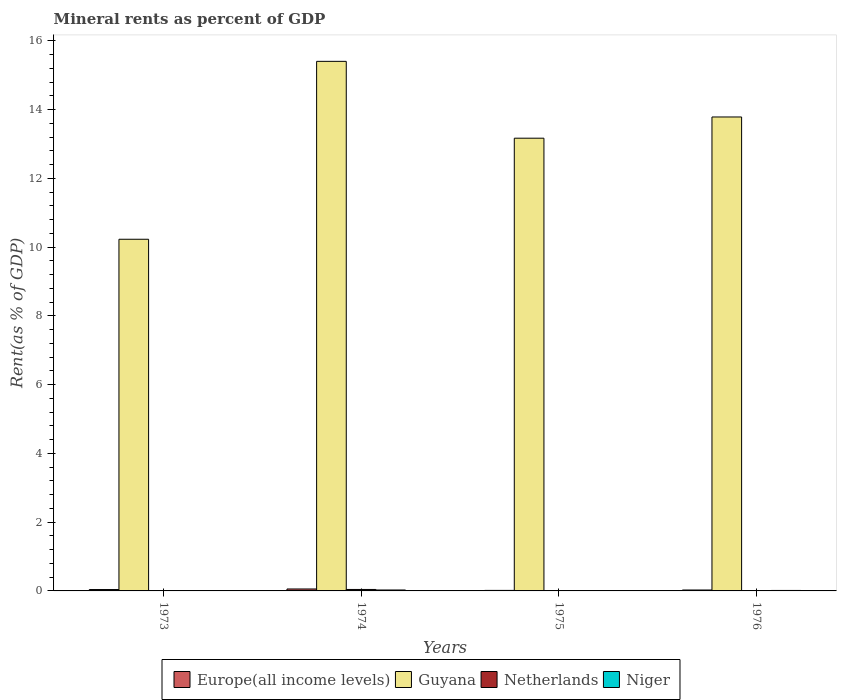Are the number of bars on each tick of the X-axis equal?
Offer a very short reply. Yes. What is the label of the 2nd group of bars from the left?
Make the answer very short. 1974. In how many cases, is the number of bars for a given year not equal to the number of legend labels?
Your answer should be compact. 0. What is the mineral rent in Netherlands in 1976?
Make the answer very short. 0. Across all years, what is the maximum mineral rent in Netherlands?
Provide a succinct answer. 0.04. Across all years, what is the minimum mineral rent in Netherlands?
Your response must be concise. 0. In which year was the mineral rent in Guyana maximum?
Keep it short and to the point. 1974. What is the total mineral rent in Niger in the graph?
Provide a succinct answer. 0.05. What is the difference between the mineral rent in Europe(all income levels) in 1974 and that in 1976?
Give a very brief answer. 0.03. What is the difference between the mineral rent in Guyana in 1973 and the mineral rent in Netherlands in 1976?
Offer a terse response. 10.23. What is the average mineral rent in Niger per year?
Your response must be concise. 0.01. In the year 1975, what is the difference between the mineral rent in Guyana and mineral rent in Europe(all income levels)?
Offer a very short reply. 13.15. What is the ratio of the mineral rent in Niger in 1973 to that in 1976?
Make the answer very short. 0.27. Is the mineral rent in Netherlands in 1974 less than that in 1976?
Ensure brevity in your answer.  No. What is the difference between the highest and the second highest mineral rent in Europe(all income levels)?
Give a very brief answer. 0.02. What is the difference between the highest and the lowest mineral rent in Netherlands?
Give a very brief answer. 0.04. Is the sum of the mineral rent in Europe(all income levels) in 1974 and 1976 greater than the maximum mineral rent in Niger across all years?
Keep it short and to the point. Yes. What does the 4th bar from the left in 1974 represents?
Your answer should be very brief. Niger. What does the 1st bar from the right in 1974 represents?
Your answer should be very brief. Niger. How many years are there in the graph?
Make the answer very short. 4. Where does the legend appear in the graph?
Ensure brevity in your answer.  Bottom center. How many legend labels are there?
Provide a succinct answer. 4. How are the legend labels stacked?
Offer a very short reply. Horizontal. What is the title of the graph?
Ensure brevity in your answer.  Mineral rents as percent of GDP. What is the label or title of the X-axis?
Provide a short and direct response. Years. What is the label or title of the Y-axis?
Your answer should be very brief. Rent(as % of GDP). What is the Rent(as % of GDP) of Europe(all income levels) in 1973?
Your answer should be compact. 0.04. What is the Rent(as % of GDP) in Guyana in 1973?
Give a very brief answer. 10.23. What is the Rent(as % of GDP) of Netherlands in 1973?
Give a very brief answer. 0.01. What is the Rent(as % of GDP) of Niger in 1973?
Ensure brevity in your answer.  0. What is the Rent(as % of GDP) of Europe(all income levels) in 1974?
Offer a very short reply. 0.06. What is the Rent(as % of GDP) of Guyana in 1974?
Offer a terse response. 15.4. What is the Rent(as % of GDP) in Netherlands in 1974?
Ensure brevity in your answer.  0.04. What is the Rent(as % of GDP) of Niger in 1974?
Provide a short and direct response. 0.03. What is the Rent(as % of GDP) in Europe(all income levels) in 1975?
Your answer should be very brief. 0.02. What is the Rent(as % of GDP) in Guyana in 1975?
Your answer should be very brief. 13.17. What is the Rent(as % of GDP) of Netherlands in 1975?
Make the answer very short. 0. What is the Rent(as % of GDP) of Niger in 1975?
Provide a succinct answer. 0.01. What is the Rent(as % of GDP) in Europe(all income levels) in 1976?
Provide a succinct answer. 0.03. What is the Rent(as % of GDP) of Guyana in 1976?
Offer a terse response. 13.78. What is the Rent(as % of GDP) in Netherlands in 1976?
Offer a terse response. 0. What is the Rent(as % of GDP) of Niger in 1976?
Give a very brief answer. 0.01. Across all years, what is the maximum Rent(as % of GDP) of Europe(all income levels)?
Make the answer very short. 0.06. Across all years, what is the maximum Rent(as % of GDP) in Guyana?
Give a very brief answer. 15.4. Across all years, what is the maximum Rent(as % of GDP) in Netherlands?
Keep it short and to the point. 0.04. Across all years, what is the maximum Rent(as % of GDP) of Niger?
Your response must be concise. 0.03. Across all years, what is the minimum Rent(as % of GDP) of Europe(all income levels)?
Provide a succinct answer. 0.02. Across all years, what is the minimum Rent(as % of GDP) of Guyana?
Give a very brief answer. 10.23. Across all years, what is the minimum Rent(as % of GDP) of Netherlands?
Give a very brief answer. 0. Across all years, what is the minimum Rent(as % of GDP) of Niger?
Give a very brief answer. 0. What is the total Rent(as % of GDP) of Europe(all income levels) in the graph?
Your answer should be compact. 0.14. What is the total Rent(as % of GDP) in Guyana in the graph?
Provide a short and direct response. 52.58. What is the total Rent(as % of GDP) of Netherlands in the graph?
Your answer should be very brief. 0.06. What is the total Rent(as % of GDP) of Niger in the graph?
Provide a succinct answer. 0.05. What is the difference between the Rent(as % of GDP) in Europe(all income levels) in 1973 and that in 1974?
Ensure brevity in your answer.  -0.02. What is the difference between the Rent(as % of GDP) of Guyana in 1973 and that in 1974?
Give a very brief answer. -5.17. What is the difference between the Rent(as % of GDP) in Netherlands in 1973 and that in 1974?
Ensure brevity in your answer.  -0.03. What is the difference between the Rent(as % of GDP) of Niger in 1973 and that in 1974?
Offer a very short reply. -0.02. What is the difference between the Rent(as % of GDP) in Europe(all income levels) in 1973 and that in 1975?
Ensure brevity in your answer.  0.02. What is the difference between the Rent(as % of GDP) in Guyana in 1973 and that in 1975?
Provide a succinct answer. -2.94. What is the difference between the Rent(as % of GDP) in Netherlands in 1973 and that in 1975?
Provide a short and direct response. 0.01. What is the difference between the Rent(as % of GDP) in Niger in 1973 and that in 1975?
Make the answer very short. -0. What is the difference between the Rent(as % of GDP) in Europe(all income levels) in 1973 and that in 1976?
Your answer should be very brief. 0.01. What is the difference between the Rent(as % of GDP) in Guyana in 1973 and that in 1976?
Give a very brief answer. -3.56. What is the difference between the Rent(as % of GDP) of Netherlands in 1973 and that in 1976?
Your answer should be compact. 0.01. What is the difference between the Rent(as % of GDP) of Niger in 1973 and that in 1976?
Make the answer very short. -0.01. What is the difference between the Rent(as % of GDP) in Europe(all income levels) in 1974 and that in 1975?
Provide a short and direct response. 0.04. What is the difference between the Rent(as % of GDP) of Guyana in 1974 and that in 1975?
Provide a short and direct response. 2.23. What is the difference between the Rent(as % of GDP) of Netherlands in 1974 and that in 1975?
Offer a terse response. 0.04. What is the difference between the Rent(as % of GDP) of Niger in 1974 and that in 1975?
Your answer should be compact. 0.02. What is the difference between the Rent(as % of GDP) of Europe(all income levels) in 1974 and that in 1976?
Offer a very short reply. 0.03. What is the difference between the Rent(as % of GDP) in Guyana in 1974 and that in 1976?
Offer a terse response. 1.62. What is the difference between the Rent(as % of GDP) of Netherlands in 1974 and that in 1976?
Your answer should be very brief. 0.04. What is the difference between the Rent(as % of GDP) of Niger in 1974 and that in 1976?
Your answer should be very brief. 0.01. What is the difference between the Rent(as % of GDP) of Europe(all income levels) in 1975 and that in 1976?
Your response must be concise. -0.01. What is the difference between the Rent(as % of GDP) of Guyana in 1975 and that in 1976?
Your answer should be compact. -0.62. What is the difference between the Rent(as % of GDP) in Netherlands in 1975 and that in 1976?
Your answer should be compact. 0. What is the difference between the Rent(as % of GDP) in Niger in 1975 and that in 1976?
Make the answer very short. -0.01. What is the difference between the Rent(as % of GDP) of Europe(all income levels) in 1973 and the Rent(as % of GDP) of Guyana in 1974?
Provide a short and direct response. -15.36. What is the difference between the Rent(as % of GDP) of Europe(all income levels) in 1973 and the Rent(as % of GDP) of Netherlands in 1974?
Your answer should be very brief. -0. What is the difference between the Rent(as % of GDP) of Europe(all income levels) in 1973 and the Rent(as % of GDP) of Niger in 1974?
Give a very brief answer. 0.01. What is the difference between the Rent(as % of GDP) in Guyana in 1973 and the Rent(as % of GDP) in Netherlands in 1974?
Keep it short and to the point. 10.19. What is the difference between the Rent(as % of GDP) in Guyana in 1973 and the Rent(as % of GDP) in Niger in 1974?
Offer a terse response. 10.2. What is the difference between the Rent(as % of GDP) of Netherlands in 1973 and the Rent(as % of GDP) of Niger in 1974?
Provide a succinct answer. -0.02. What is the difference between the Rent(as % of GDP) of Europe(all income levels) in 1973 and the Rent(as % of GDP) of Guyana in 1975?
Provide a short and direct response. -13.13. What is the difference between the Rent(as % of GDP) of Europe(all income levels) in 1973 and the Rent(as % of GDP) of Netherlands in 1975?
Give a very brief answer. 0.04. What is the difference between the Rent(as % of GDP) in Europe(all income levels) in 1973 and the Rent(as % of GDP) in Niger in 1975?
Offer a very short reply. 0.03. What is the difference between the Rent(as % of GDP) in Guyana in 1973 and the Rent(as % of GDP) in Netherlands in 1975?
Your response must be concise. 10.23. What is the difference between the Rent(as % of GDP) of Guyana in 1973 and the Rent(as % of GDP) of Niger in 1975?
Give a very brief answer. 10.22. What is the difference between the Rent(as % of GDP) of Netherlands in 1973 and the Rent(as % of GDP) of Niger in 1975?
Make the answer very short. 0. What is the difference between the Rent(as % of GDP) of Europe(all income levels) in 1973 and the Rent(as % of GDP) of Guyana in 1976?
Your answer should be compact. -13.74. What is the difference between the Rent(as % of GDP) in Europe(all income levels) in 1973 and the Rent(as % of GDP) in Netherlands in 1976?
Provide a succinct answer. 0.04. What is the difference between the Rent(as % of GDP) of Europe(all income levels) in 1973 and the Rent(as % of GDP) of Niger in 1976?
Your answer should be compact. 0.03. What is the difference between the Rent(as % of GDP) in Guyana in 1973 and the Rent(as % of GDP) in Netherlands in 1976?
Offer a terse response. 10.23. What is the difference between the Rent(as % of GDP) of Guyana in 1973 and the Rent(as % of GDP) of Niger in 1976?
Your answer should be very brief. 10.21. What is the difference between the Rent(as % of GDP) of Netherlands in 1973 and the Rent(as % of GDP) of Niger in 1976?
Offer a terse response. -0. What is the difference between the Rent(as % of GDP) in Europe(all income levels) in 1974 and the Rent(as % of GDP) in Guyana in 1975?
Provide a succinct answer. -13.11. What is the difference between the Rent(as % of GDP) in Europe(all income levels) in 1974 and the Rent(as % of GDP) in Netherlands in 1975?
Your answer should be compact. 0.05. What is the difference between the Rent(as % of GDP) of Europe(all income levels) in 1974 and the Rent(as % of GDP) of Niger in 1975?
Give a very brief answer. 0.05. What is the difference between the Rent(as % of GDP) in Guyana in 1974 and the Rent(as % of GDP) in Netherlands in 1975?
Ensure brevity in your answer.  15.4. What is the difference between the Rent(as % of GDP) in Guyana in 1974 and the Rent(as % of GDP) in Niger in 1975?
Your answer should be compact. 15.39. What is the difference between the Rent(as % of GDP) in Netherlands in 1974 and the Rent(as % of GDP) in Niger in 1975?
Give a very brief answer. 0.03. What is the difference between the Rent(as % of GDP) of Europe(all income levels) in 1974 and the Rent(as % of GDP) of Guyana in 1976?
Provide a short and direct response. -13.73. What is the difference between the Rent(as % of GDP) in Europe(all income levels) in 1974 and the Rent(as % of GDP) in Netherlands in 1976?
Keep it short and to the point. 0.06. What is the difference between the Rent(as % of GDP) of Europe(all income levels) in 1974 and the Rent(as % of GDP) of Niger in 1976?
Offer a very short reply. 0.04. What is the difference between the Rent(as % of GDP) in Guyana in 1974 and the Rent(as % of GDP) in Netherlands in 1976?
Keep it short and to the point. 15.4. What is the difference between the Rent(as % of GDP) in Guyana in 1974 and the Rent(as % of GDP) in Niger in 1976?
Provide a short and direct response. 15.39. What is the difference between the Rent(as % of GDP) of Netherlands in 1974 and the Rent(as % of GDP) of Niger in 1976?
Offer a very short reply. 0.03. What is the difference between the Rent(as % of GDP) of Europe(all income levels) in 1975 and the Rent(as % of GDP) of Guyana in 1976?
Your response must be concise. -13.77. What is the difference between the Rent(as % of GDP) in Europe(all income levels) in 1975 and the Rent(as % of GDP) in Netherlands in 1976?
Provide a short and direct response. 0.01. What is the difference between the Rent(as % of GDP) in Europe(all income levels) in 1975 and the Rent(as % of GDP) in Niger in 1976?
Provide a succinct answer. 0. What is the difference between the Rent(as % of GDP) in Guyana in 1975 and the Rent(as % of GDP) in Netherlands in 1976?
Give a very brief answer. 13.17. What is the difference between the Rent(as % of GDP) in Guyana in 1975 and the Rent(as % of GDP) in Niger in 1976?
Your answer should be very brief. 13.15. What is the difference between the Rent(as % of GDP) in Netherlands in 1975 and the Rent(as % of GDP) in Niger in 1976?
Your answer should be very brief. -0.01. What is the average Rent(as % of GDP) of Europe(all income levels) per year?
Give a very brief answer. 0.03. What is the average Rent(as % of GDP) in Guyana per year?
Your response must be concise. 13.15. What is the average Rent(as % of GDP) of Netherlands per year?
Your answer should be compact. 0.01. What is the average Rent(as % of GDP) of Niger per year?
Offer a very short reply. 0.01. In the year 1973, what is the difference between the Rent(as % of GDP) in Europe(all income levels) and Rent(as % of GDP) in Guyana?
Offer a terse response. -10.19. In the year 1973, what is the difference between the Rent(as % of GDP) of Europe(all income levels) and Rent(as % of GDP) of Netherlands?
Offer a terse response. 0.03. In the year 1973, what is the difference between the Rent(as % of GDP) in Europe(all income levels) and Rent(as % of GDP) in Niger?
Keep it short and to the point. 0.04. In the year 1973, what is the difference between the Rent(as % of GDP) in Guyana and Rent(as % of GDP) in Netherlands?
Keep it short and to the point. 10.22. In the year 1973, what is the difference between the Rent(as % of GDP) of Guyana and Rent(as % of GDP) of Niger?
Provide a succinct answer. 10.22. In the year 1973, what is the difference between the Rent(as % of GDP) of Netherlands and Rent(as % of GDP) of Niger?
Provide a short and direct response. 0.01. In the year 1974, what is the difference between the Rent(as % of GDP) of Europe(all income levels) and Rent(as % of GDP) of Guyana?
Give a very brief answer. -15.35. In the year 1974, what is the difference between the Rent(as % of GDP) in Europe(all income levels) and Rent(as % of GDP) in Netherlands?
Provide a succinct answer. 0.01. In the year 1974, what is the difference between the Rent(as % of GDP) of Europe(all income levels) and Rent(as % of GDP) of Niger?
Ensure brevity in your answer.  0.03. In the year 1974, what is the difference between the Rent(as % of GDP) in Guyana and Rent(as % of GDP) in Netherlands?
Provide a succinct answer. 15.36. In the year 1974, what is the difference between the Rent(as % of GDP) in Guyana and Rent(as % of GDP) in Niger?
Your answer should be compact. 15.38. In the year 1974, what is the difference between the Rent(as % of GDP) of Netherlands and Rent(as % of GDP) of Niger?
Keep it short and to the point. 0.02. In the year 1975, what is the difference between the Rent(as % of GDP) of Europe(all income levels) and Rent(as % of GDP) of Guyana?
Your response must be concise. -13.15. In the year 1975, what is the difference between the Rent(as % of GDP) in Europe(all income levels) and Rent(as % of GDP) in Netherlands?
Your answer should be compact. 0.01. In the year 1975, what is the difference between the Rent(as % of GDP) in Europe(all income levels) and Rent(as % of GDP) in Niger?
Your answer should be very brief. 0.01. In the year 1975, what is the difference between the Rent(as % of GDP) in Guyana and Rent(as % of GDP) in Netherlands?
Your response must be concise. 13.17. In the year 1975, what is the difference between the Rent(as % of GDP) of Guyana and Rent(as % of GDP) of Niger?
Your answer should be very brief. 13.16. In the year 1975, what is the difference between the Rent(as % of GDP) of Netherlands and Rent(as % of GDP) of Niger?
Keep it short and to the point. -0.01. In the year 1976, what is the difference between the Rent(as % of GDP) of Europe(all income levels) and Rent(as % of GDP) of Guyana?
Offer a very short reply. -13.76. In the year 1976, what is the difference between the Rent(as % of GDP) of Europe(all income levels) and Rent(as % of GDP) of Netherlands?
Your response must be concise. 0.03. In the year 1976, what is the difference between the Rent(as % of GDP) in Europe(all income levels) and Rent(as % of GDP) in Niger?
Provide a short and direct response. 0.01. In the year 1976, what is the difference between the Rent(as % of GDP) of Guyana and Rent(as % of GDP) of Netherlands?
Ensure brevity in your answer.  13.78. In the year 1976, what is the difference between the Rent(as % of GDP) of Guyana and Rent(as % of GDP) of Niger?
Keep it short and to the point. 13.77. In the year 1976, what is the difference between the Rent(as % of GDP) in Netherlands and Rent(as % of GDP) in Niger?
Ensure brevity in your answer.  -0.01. What is the ratio of the Rent(as % of GDP) in Europe(all income levels) in 1973 to that in 1974?
Your answer should be very brief. 0.71. What is the ratio of the Rent(as % of GDP) of Guyana in 1973 to that in 1974?
Make the answer very short. 0.66. What is the ratio of the Rent(as % of GDP) in Netherlands in 1973 to that in 1974?
Ensure brevity in your answer.  0.27. What is the ratio of the Rent(as % of GDP) of Niger in 1973 to that in 1974?
Offer a terse response. 0.14. What is the ratio of the Rent(as % of GDP) of Europe(all income levels) in 1973 to that in 1975?
Offer a terse response. 2.63. What is the ratio of the Rent(as % of GDP) of Guyana in 1973 to that in 1975?
Give a very brief answer. 0.78. What is the ratio of the Rent(as % of GDP) in Netherlands in 1973 to that in 1975?
Ensure brevity in your answer.  5.97. What is the ratio of the Rent(as % of GDP) in Niger in 1973 to that in 1975?
Give a very brief answer. 0.46. What is the ratio of the Rent(as % of GDP) in Europe(all income levels) in 1973 to that in 1976?
Your answer should be very brief. 1.5. What is the ratio of the Rent(as % of GDP) in Guyana in 1973 to that in 1976?
Your answer should be compact. 0.74. What is the ratio of the Rent(as % of GDP) in Netherlands in 1973 to that in 1976?
Your answer should be compact. 21.57. What is the ratio of the Rent(as % of GDP) in Niger in 1973 to that in 1976?
Ensure brevity in your answer.  0.27. What is the ratio of the Rent(as % of GDP) of Europe(all income levels) in 1974 to that in 1975?
Offer a very short reply. 3.7. What is the ratio of the Rent(as % of GDP) of Guyana in 1974 to that in 1975?
Offer a terse response. 1.17. What is the ratio of the Rent(as % of GDP) of Netherlands in 1974 to that in 1975?
Provide a succinct answer. 22.01. What is the ratio of the Rent(as % of GDP) in Niger in 1974 to that in 1975?
Your answer should be very brief. 3.29. What is the ratio of the Rent(as % of GDP) of Europe(all income levels) in 1974 to that in 1976?
Your answer should be compact. 2.11. What is the ratio of the Rent(as % of GDP) of Guyana in 1974 to that in 1976?
Your answer should be compact. 1.12. What is the ratio of the Rent(as % of GDP) of Netherlands in 1974 to that in 1976?
Provide a short and direct response. 79.49. What is the ratio of the Rent(as % of GDP) of Niger in 1974 to that in 1976?
Give a very brief answer. 1.92. What is the ratio of the Rent(as % of GDP) in Europe(all income levels) in 1975 to that in 1976?
Ensure brevity in your answer.  0.57. What is the ratio of the Rent(as % of GDP) of Guyana in 1975 to that in 1976?
Give a very brief answer. 0.96. What is the ratio of the Rent(as % of GDP) of Netherlands in 1975 to that in 1976?
Your response must be concise. 3.61. What is the ratio of the Rent(as % of GDP) in Niger in 1975 to that in 1976?
Offer a terse response. 0.58. What is the difference between the highest and the second highest Rent(as % of GDP) in Europe(all income levels)?
Make the answer very short. 0.02. What is the difference between the highest and the second highest Rent(as % of GDP) of Guyana?
Your response must be concise. 1.62. What is the difference between the highest and the second highest Rent(as % of GDP) of Netherlands?
Keep it short and to the point. 0.03. What is the difference between the highest and the second highest Rent(as % of GDP) in Niger?
Offer a very short reply. 0.01. What is the difference between the highest and the lowest Rent(as % of GDP) in Europe(all income levels)?
Offer a terse response. 0.04. What is the difference between the highest and the lowest Rent(as % of GDP) of Guyana?
Provide a short and direct response. 5.17. What is the difference between the highest and the lowest Rent(as % of GDP) of Netherlands?
Give a very brief answer. 0.04. What is the difference between the highest and the lowest Rent(as % of GDP) of Niger?
Keep it short and to the point. 0.02. 